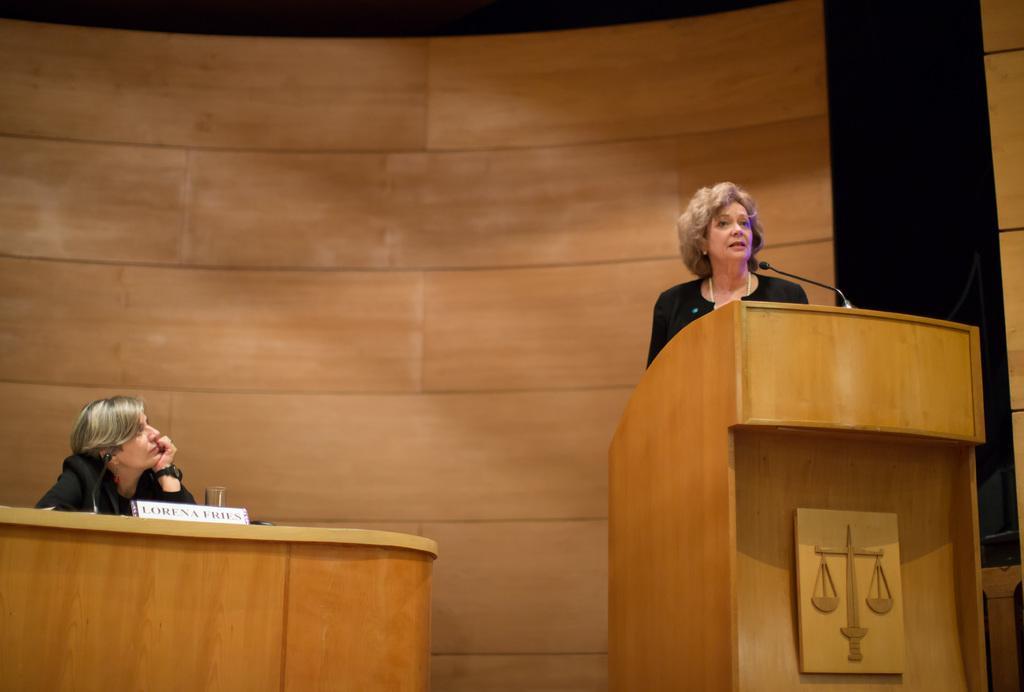In one or two sentences, can you explain what this image depicts? In this picture we can see the woman wearing black dress, standing at the wooden speech desk and giving a speech. Behind there is a wooden panel wall. On the left side there is a woman sitting and listening and her. 